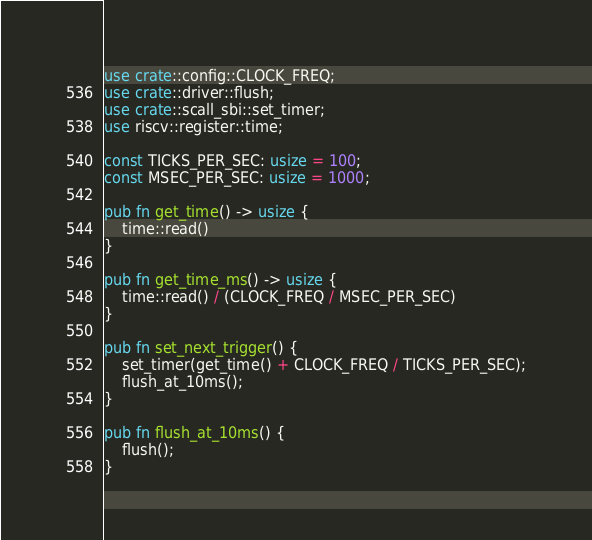Convert code to text. <code><loc_0><loc_0><loc_500><loc_500><_Rust_>use crate::config::CLOCK_FREQ;
use crate::driver::flush;
use crate::scall_sbi::set_timer;
use riscv::register::time;

const TICKS_PER_SEC: usize = 100;
const MSEC_PER_SEC: usize = 1000;

pub fn get_time() -> usize {
    time::read()
}

pub fn get_time_ms() -> usize {
    time::read() / (CLOCK_FREQ / MSEC_PER_SEC)
}

pub fn set_next_trigger() {
    set_timer(get_time() + CLOCK_FREQ / TICKS_PER_SEC);
    flush_at_10ms();
}

pub fn flush_at_10ms() {
    flush();
}
</code> 